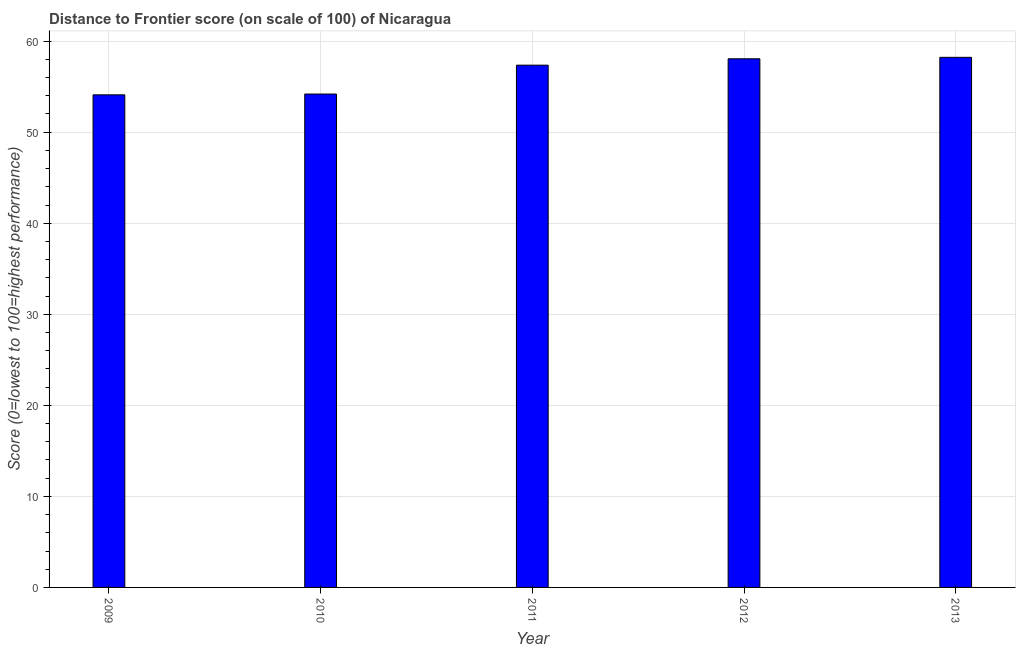Does the graph contain grids?
Ensure brevity in your answer.  Yes. What is the title of the graph?
Your answer should be compact. Distance to Frontier score (on scale of 100) of Nicaragua. What is the label or title of the Y-axis?
Give a very brief answer. Score (0=lowest to 100=highest performance). What is the distance to frontier score in 2009?
Offer a very short reply. 54.1. Across all years, what is the maximum distance to frontier score?
Keep it short and to the point. 58.22. Across all years, what is the minimum distance to frontier score?
Give a very brief answer. 54.1. In which year was the distance to frontier score maximum?
Your response must be concise. 2013. What is the sum of the distance to frontier score?
Make the answer very short. 281.93. What is the difference between the distance to frontier score in 2012 and 2013?
Offer a terse response. -0.16. What is the average distance to frontier score per year?
Provide a succinct answer. 56.39. What is the median distance to frontier score?
Ensure brevity in your answer.  57.36. Do a majority of the years between 2011 and 2010 (inclusive) have distance to frontier score greater than 54 ?
Your answer should be very brief. No. What is the ratio of the distance to frontier score in 2009 to that in 2011?
Your answer should be very brief. 0.94. Is the difference between the distance to frontier score in 2010 and 2013 greater than the difference between any two years?
Offer a terse response. No. What is the difference between the highest and the second highest distance to frontier score?
Offer a terse response. 0.16. What is the difference between the highest and the lowest distance to frontier score?
Provide a short and direct response. 4.12. In how many years, is the distance to frontier score greater than the average distance to frontier score taken over all years?
Offer a very short reply. 3. Are all the bars in the graph horizontal?
Ensure brevity in your answer.  No. What is the difference between two consecutive major ticks on the Y-axis?
Your answer should be very brief. 10. What is the Score (0=lowest to 100=highest performance) of 2009?
Your answer should be compact. 54.1. What is the Score (0=lowest to 100=highest performance) in 2010?
Offer a very short reply. 54.19. What is the Score (0=lowest to 100=highest performance) in 2011?
Make the answer very short. 57.36. What is the Score (0=lowest to 100=highest performance) in 2012?
Keep it short and to the point. 58.06. What is the Score (0=lowest to 100=highest performance) of 2013?
Make the answer very short. 58.22. What is the difference between the Score (0=lowest to 100=highest performance) in 2009 and 2010?
Offer a very short reply. -0.09. What is the difference between the Score (0=lowest to 100=highest performance) in 2009 and 2011?
Your answer should be very brief. -3.26. What is the difference between the Score (0=lowest to 100=highest performance) in 2009 and 2012?
Keep it short and to the point. -3.96. What is the difference between the Score (0=lowest to 100=highest performance) in 2009 and 2013?
Provide a succinct answer. -4.12. What is the difference between the Score (0=lowest to 100=highest performance) in 2010 and 2011?
Make the answer very short. -3.17. What is the difference between the Score (0=lowest to 100=highest performance) in 2010 and 2012?
Provide a succinct answer. -3.87. What is the difference between the Score (0=lowest to 100=highest performance) in 2010 and 2013?
Offer a very short reply. -4.03. What is the difference between the Score (0=lowest to 100=highest performance) in 2011 and 2012?
Your response must be concise. -0.7. What is the difference between the Score (0=lowest to 100=highest performance) in 2011 and 2013?
Offer a very short reply. -0.86. What is the difference between the Score (0=lowest to 100=highest performance) in 2012 and 2013?
Offer a very short reply. -0.16. What is the ratio of the Score (0=lowest to 100=highest performance) in 2009 to that in 2010?
Offer a very short reply. 1. What is the ratio of the Score (0=lowest to 100=highest performance) in 2009 to that in 2011?
Provide a short and direct response. 0.94. What is the ratio of the Score (0=lowest to 100=highest performance) in 2009 to that in 2012?
Offer a terse response. 0.93. What is the ratio of the Score (0=lowest to 100=highest performance) in 2009 to that in 2013?
Offer a terse response. 0.93. What is the ratio of the Score (0=lowest to 100=highest performance) in 2010 to that in 2011?
Keep it short and to the point. 0.94. What is the ratio of the Score (0=lowest to 100=highest performance) in 2010 to that in 2012?
Offer a very short reply. 0.93. What is the ratio of the Score (0=lowest to 100=highest performance) in 2011 to that in 2013?
Ensure brevity in your answer.  0.98. 